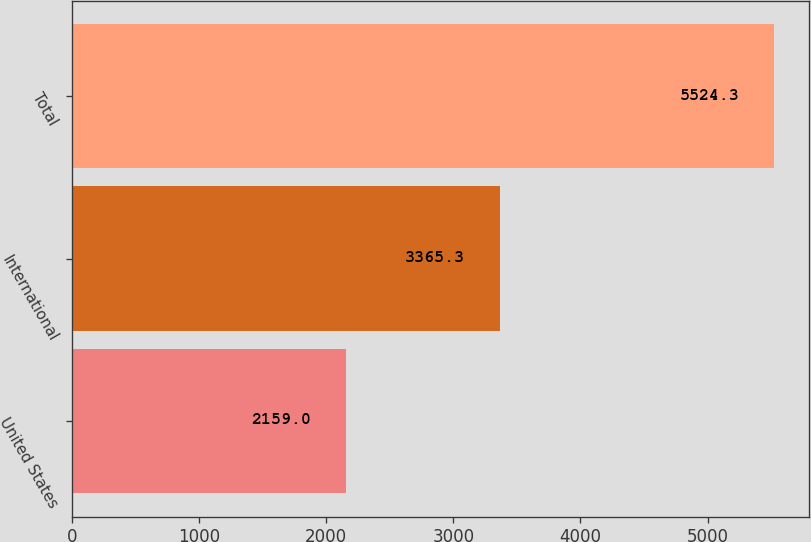Convert chart. <chart><loc_0><loc_0><loc_500><loc_500><bar_chart><fcel>United States<fcel>International<fcel>Total<nl><fcel>2159<fcel>3365.3<fcel>5524.3<nl></chart> 